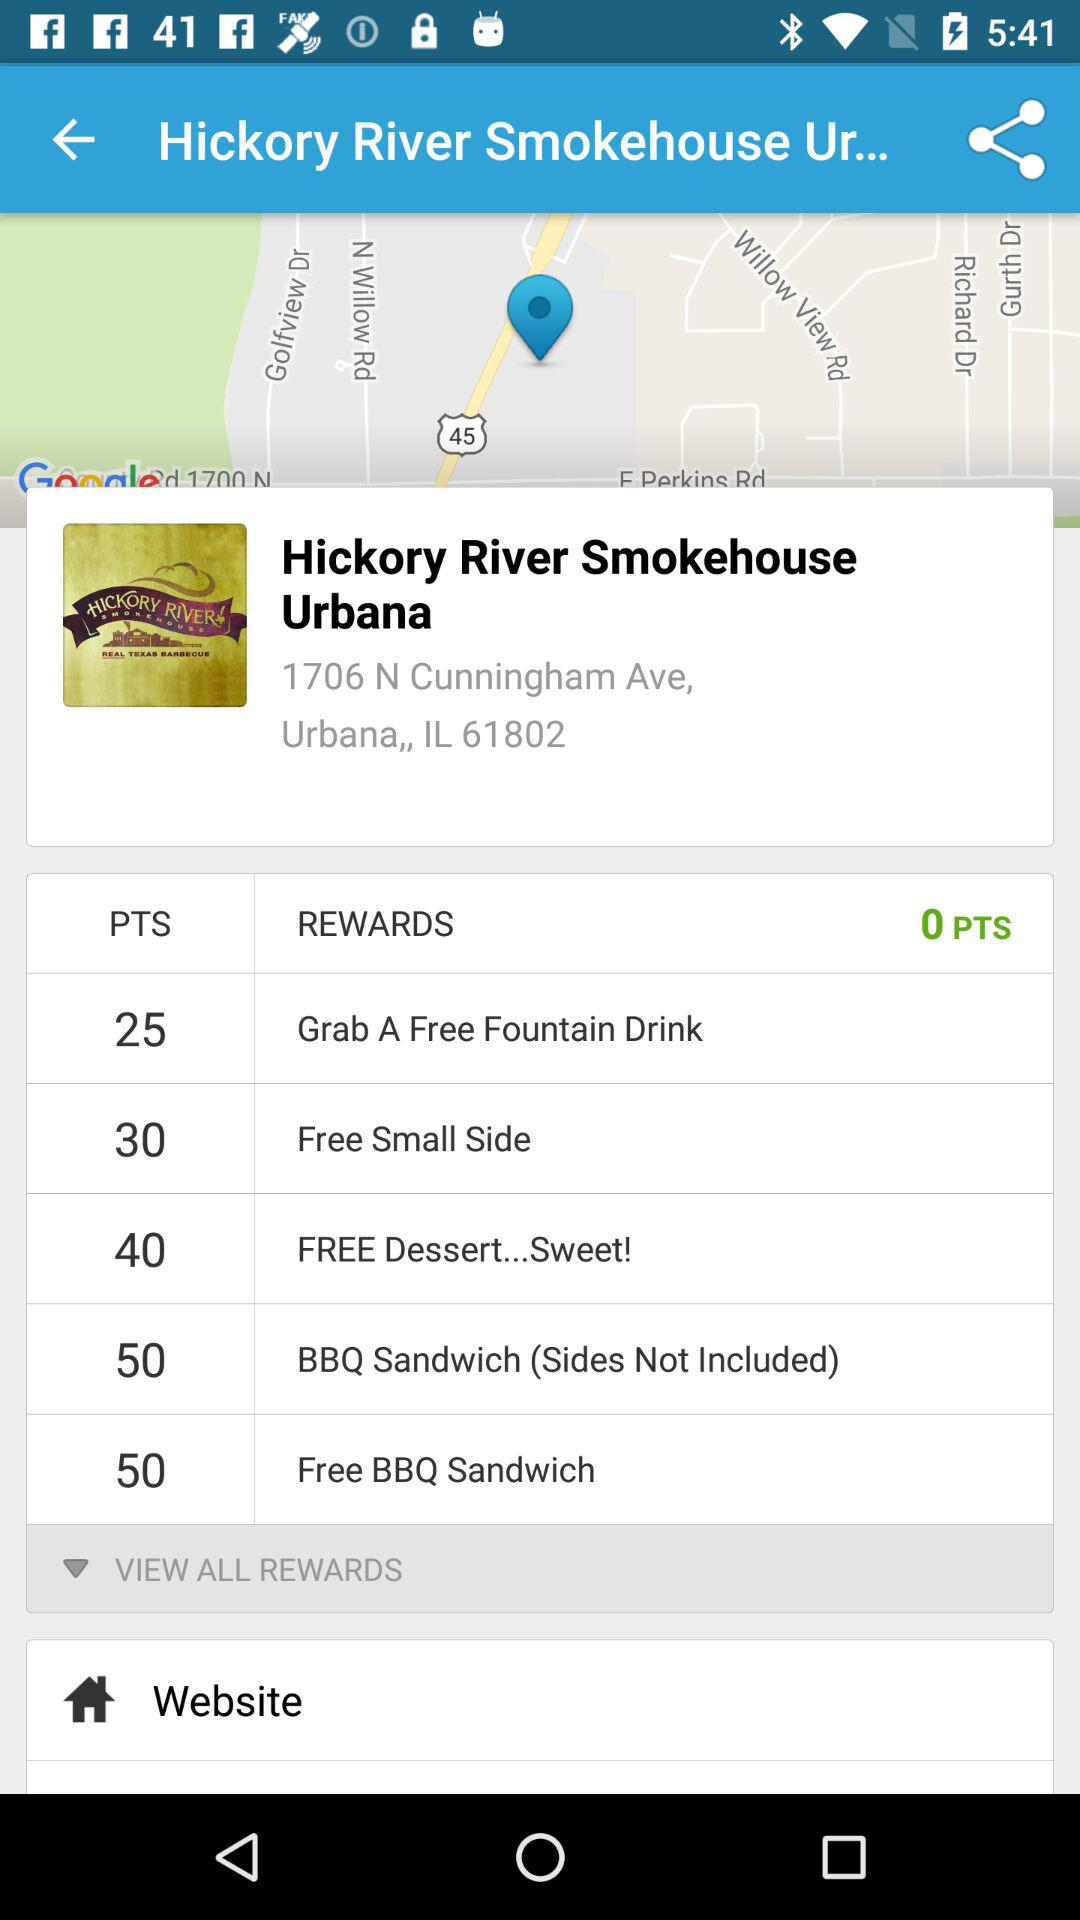What is the location of "Hickory River Smokehouse Urbana"? The location is 1706 N Cunningham Ave, Urbana, IL 61802. 